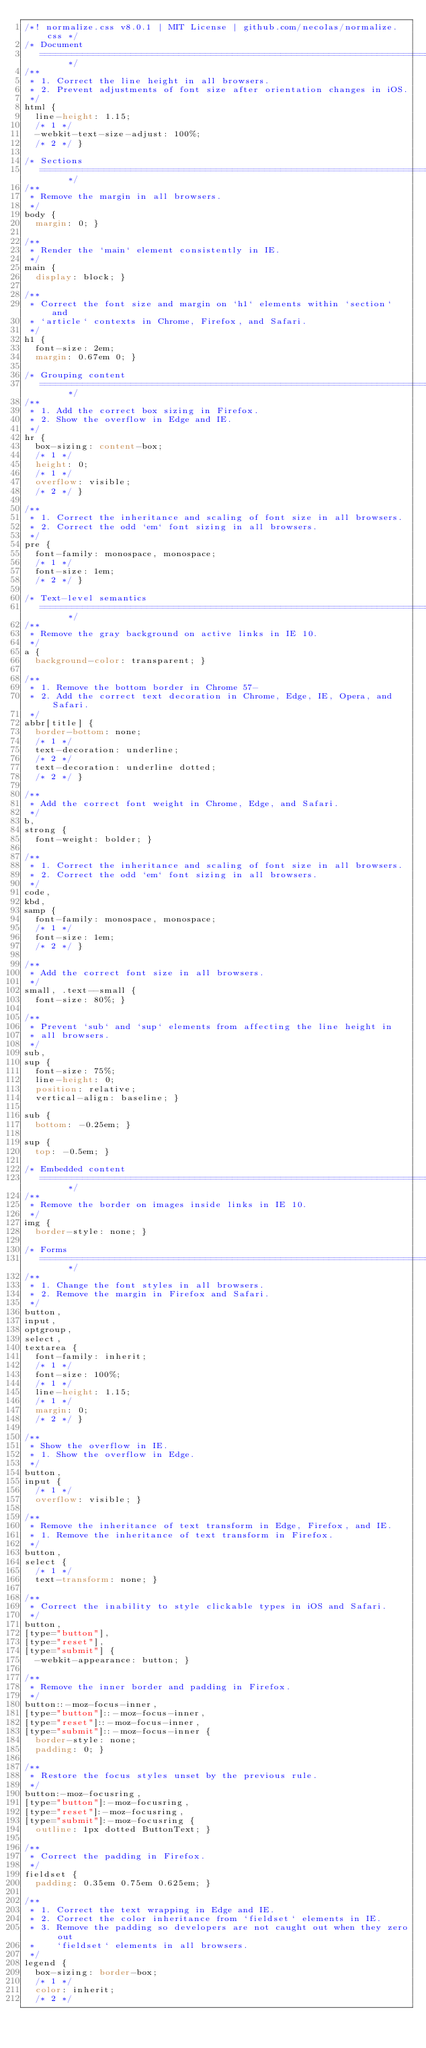<code> <loc_0><loc_0><loc_500><loc_500><_CSS_>/*! normalize.css v8.0.1 | MIT License | github.com/necolas/normalize.css */
/* Document
   ========================================================================== */
/**
 * 1. Correct the line height in all browsers.
 * 2. Prevent adjustments of font size after orientation changes in iOS.
 */
html {
  line-height: 1.15;
  /* 1 */
  -webkit-text-size-adjust: 100%;
  /* 2 */ }

/* Sections
   ========================================================================== */
/**
 * Remove the margin in all browsers.
 */
body {
  margin: 0; }

/**
 * Render the `main` element consistently in IE.
 */
main {
  display: block; }

/**
 * Correct the font size and margin on `h1` elements within `section` and
 * `article` contexts in Chrome, Firefox, and Safari.
 */
h1 {
  font-size: 2em;
  margin: 0.67em 0; }

/* Grouping content
   ========================================================================== */
/**
 * 1. Add the correct box sizing in Firefox.
 * 2. Show the overflow in Edge and IE.
 */
hr {
  box-sizing: content-box;
  /* 1 */
  height: 0;
  /* 1 */
  overflow: visible;
  /* 2 */ }

/**
 * 1. Correct the inheritance and scaling of font size in all browsers.
 * 2. Correct the odd `em` font sizing in all browsers.
 */
pre {
  font-family: monospace, monospace;
  /* 1 */
  font-size: 1em;
  /* 2 */ }

/* Text-level semantics
   ========================================================================== */
/**
 * Remove the gray background on active links in IE 10.
 */
a {
  background-color: transparent; }

/**
 * 1. Remove the bottom border in Chrome 57-
 * 2. Add the correct text decoration in Chrome, Edge, IE, Opera, and Safari.
 */
abbr[title] {
  border-bottom: none;
  /* 1 */
  text-decoration: underline;
  /* 2 */
  text-decoration: underline dotted;
  /* 2 */ }

/**
 * Add the correct font weight in Chrome, Edge, and Safari.
 */
b,
strong {
  font-weight: bolder; }

/**
 * 1. Correct the inheritance and scaling of font size in all browsers.
 * 2. Correct the odd `em` font sizing in all browsers.
 */
code,
kbd,
samp {
  font-family: monospace, monospace;
  /* 1 */
  font-size: 1em;
  /* 2 */ }

/**
 * Add the correct font size in all browsers.
 */
small, .text--small {
  font-size: 80%; }

/**
 * Prevent `sub` and `sup` elements from affecting the line height in
 * all browsers.
 */
sub,
sup {
  font-size: 75%;
  line-height: 0;
  position: relative;
  vertical-align: baseline; }

sub {
  bottom: -0.25em; }

sup {
  top: -0.5em; }

/* Embedded content
   ========================================================================== */
/**
 * Remove the border on images inside links in IE 10.
 */
img {
  border-style: none; }

/* Forms
   ========================================================================== */
/**
 * 1. Change the font styles in all browsers.
 * 2. Remove the margin in Firefox and Safari.
 */
button,
input,
optgroup,
select,
textarea {
  font-family: inherit;
  /* 1 */
  font-size: 100%;
  /* 1 */
  line-height: 1.15;
  /* 1 */
  margin: 0;
  /* 2 */ }

/**
 * Show the overflow in IE.
 * 1. Show the overflow in Edge.
 */
button,
input {
  /* 1 */
  overflow: visible; }

/**
 * Remove the inheritance of text transform in Edge, Firefox, and IE.
 * 1. Remove the inheritance of text transform in Firefox.
 */
button,
select {
  /* 1 */
  text-transform: none; }

/**
 * Correct the inability to style clickable types in iOS and Safari.
 */
button,
[type="button"],
[type="reset"],
[type="submit"] {
  -webkit-appearance: button; }

/**
 * Remove the inner border and padding in Firefox.
 */
button::-moz-focus-inner,
[type="button"]::-moz-focus-inner,
[type="reset"]::-moz-focus-inner,
[type="submit"]::-moz-focus-inner {
  border-style: none;
  padding: 0; }

/**
 * Restore the focus styles unset by the previous rule.
 */
button:-moz-focusring,
[type="button"]:-moz-focusring,
[type="reset"]:-moz-focusring,
[type="submit"]:-moz-focusring {
  outline: 1px dotted ButtonText; }

/**
 * Correct the padding in Firefox.
 */
fieldset {
  padding: 0.35em 0.75em 0.625em; }

/**
 * 1. Correct the text wrapping in Edge and IE.
 * 2. Correct the color inheritance from `fieldset` elements in IE.
 * 3. Remove the padding so developers are not caught out when they zero out
 *    `fieldset` elements in all browsers.
 */
legend {
  box-sizing: border-box;
  /* 1 */
  color: inherit;
  /* 2 */</code> 